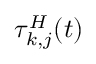<formula> <loc_0><loc_0><loc_500><loc_500>\tau _ { k , j } ^ { H } ( t )</formula> 